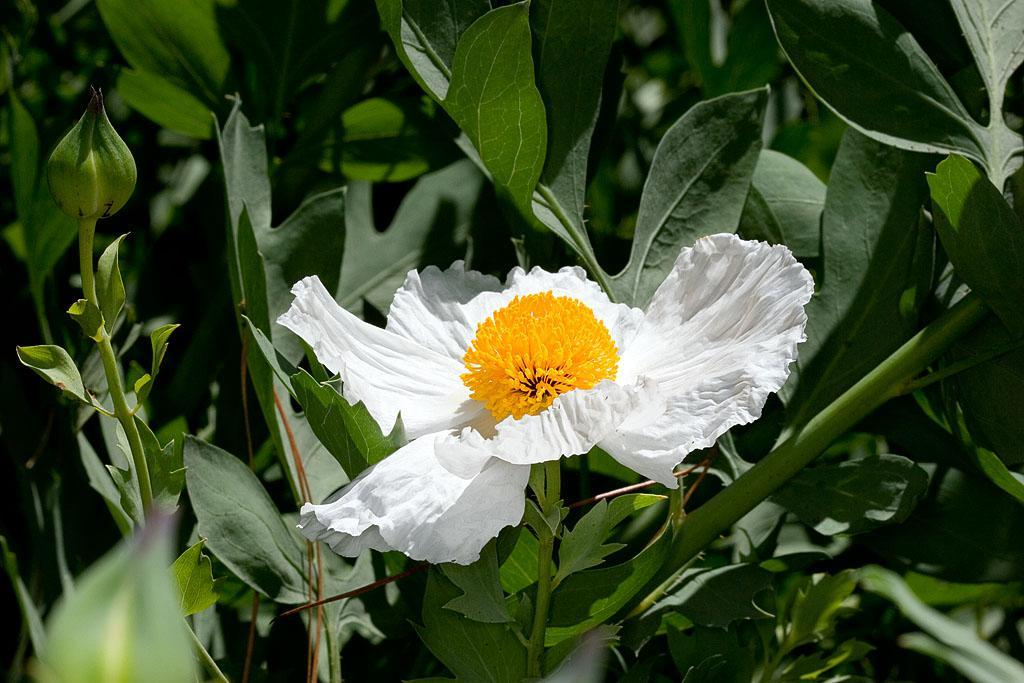What is present on the plant in the image? There is a flower on the plant. What colors can be seen on the flower? The flower has white and yellow colors. What else is present on the plant besides the flower? There are leaves on the plant. Can you see any unopened flowers on the plant? Yes, there is a flower bud on the plant. Where are the toys and kittens located in the image? There are no toys or kittens present in the image; it only features a flower on a plant with leaves and a flower bud. 